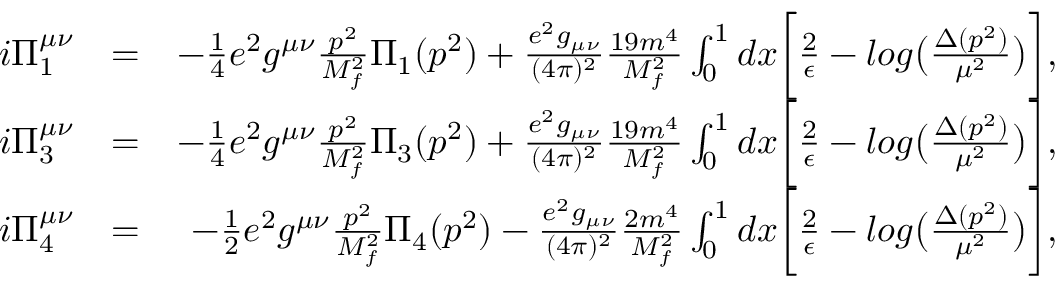<formula> <loc_0><loc_0><loc_500><loc_500>\begin{array} { r l r } { i \Pi _ { 1 } ^ { \mu \nu } } & { = } & { - \frac { 1 } { 4 } e ^ { 2 } g ^ { \mu \nu } \frac { p ^ { 2 } } { M _ { f } ^ { 2 } } \Pi _ { 1 } ( p ^ { 2 } ) + \frac { e ^ { 2 } g _ { \mu \nu } } { ( 4 \pi ) ^ { 2 } } \frac { 1 9 m ^ { 4 } } { M _ { f } ^ { 2 } } \int _ { 0 } ^ { 1 } d x \left [ \frac { 2 } { \epsilon } - \log \left ( \frac { \Delta ( p ^ { 2 } ) } { \mu ^ { 2 } } \right ) \right ] , } \\ { i \Pi _ { 3 } ^ { \mu \nu } } & { = } & { - \frac { 1 } { 4 } e ^ { 2 } g ^ { \mu \nu } \frac { p ^ { 2 } } { M _ { f } ^ { 2 } } \Pi _ { 3 } ( p ^ { 2 } ) + \frac { e ^ { 2 } g _ { \mu \nu } } { ( 4 \pi ) ^ { 2 } } \frac { 1 9 m ^ { 4 } } { M _ { f } ^ { 2 } } \int _ { 0 } ^ { 1 } d x \left [ \frac { 2 } { \epsilon } - \log \left ( \frac { \Delta ( p ^ { 2 } ) } { \mu ^ { 2 } } \right ) \right ] , } \\ { i \Pi _ { 4 } ^ { \mu \nu } } & { = } & { - \frac { 1 } { 2 } e ^ { 2 } g ^ { \mu \nu } \frac { p ^ { 2 } } { M _ { f } ^ { 2 } } \Pi _ { 4 } ( p ^ { 2 } ) - \frac { e ^ { 2 } g _ { \mu \nu } } { ( 4 \pi ) ^ { 2 } } \frac { 2 m ^ { 4 } } { M _ { f } ^ { 2 } } \int _ { 0 } ^ { 1 } d x \left [ \frac { 2 } { \epsilon } - \log \left ( \frac { \Delta ( p ^ { 2 } ) } { \mu ^ { 2 } } \right ) \right ] , } \end{array}</formula> 